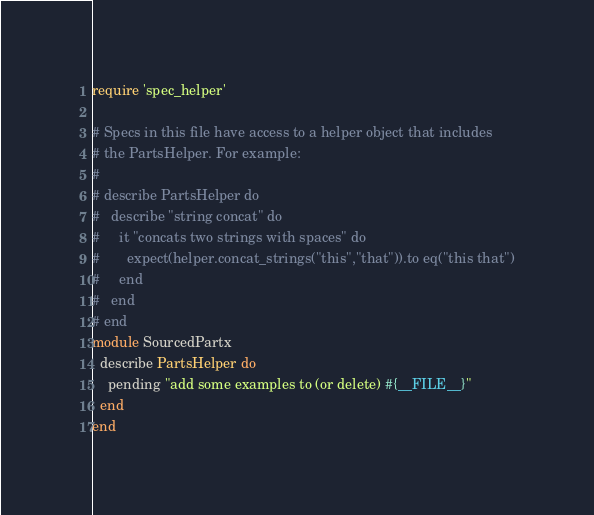Convert code to text. <code><loc_0><loc_0><loc_500><loc_500><_Ruby_>require 'spec_helper'

# Specs in this file have access to a helper object that includes
# the PartsHelper. For example:
#
# describe PartsHelper do
#   describe "string concat" do
#     it "concats two strings with spaces" do
#       expect(helper.concat_strings("this","that")).to eq("this that")
#     end
#   end
# end
module SourcedPartx
  describe PartsHelper do
    pending "add some examples to (or delete) #{__FILE__}"
  end
end
</code> 